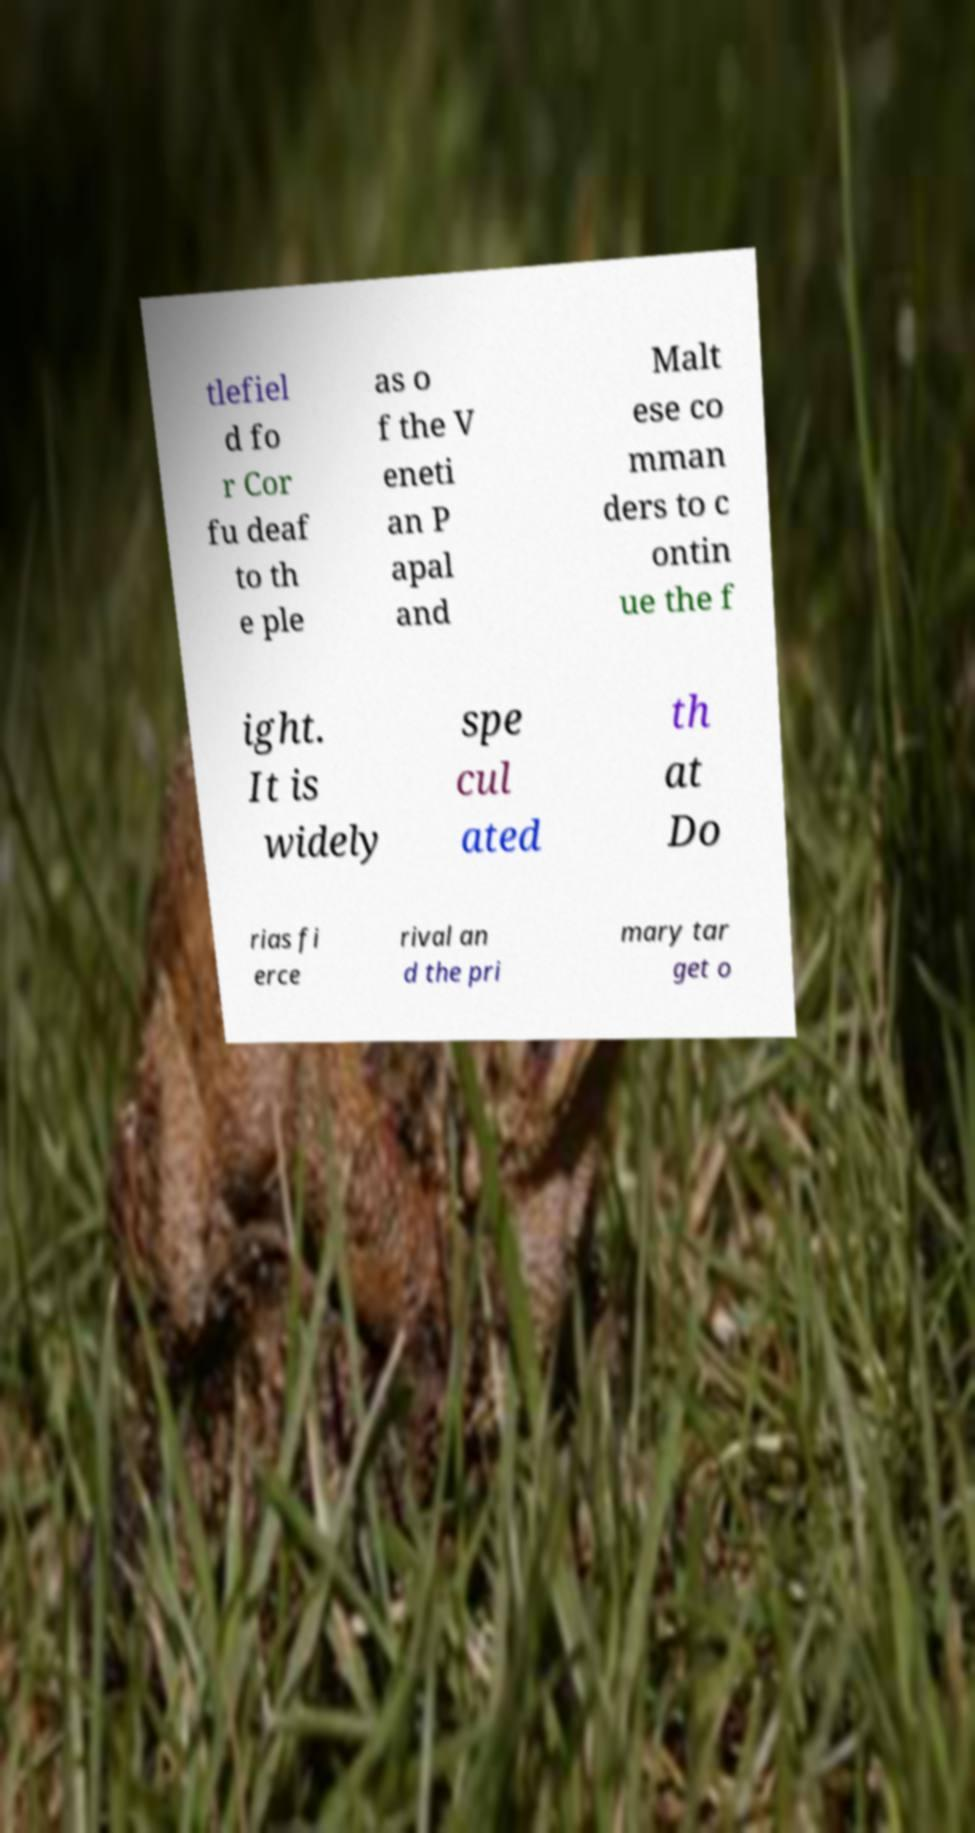Please identify and transcribe the text found in this image. tlefiel d fo r Cor fu deaf to th e ple as o f the V eneti an P apal and Malt ese co mman ders to c ontin ue the f ight. It is widely spe cul ated th at Do rias fi erce rival an d the pri mary tar get o 